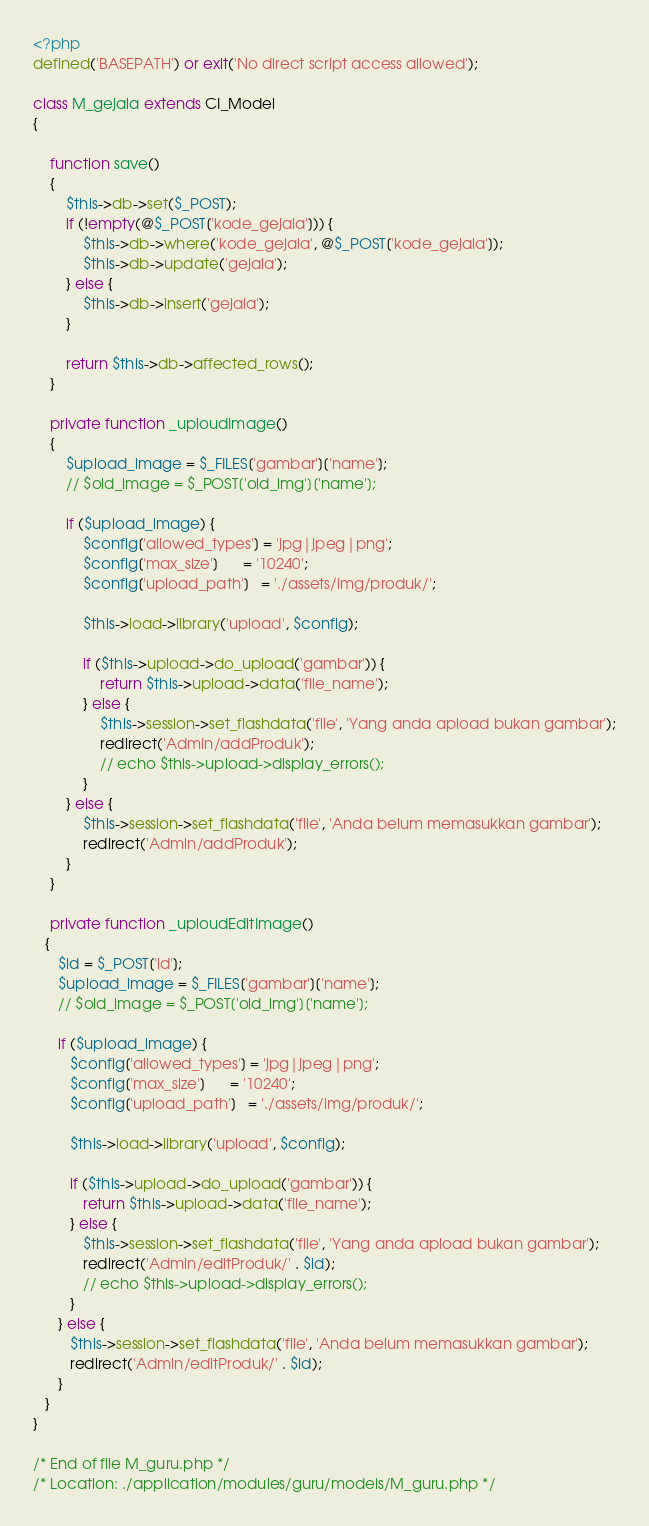Convert code to text. <code><loc_0><loc_0><loc_500><loc_500><_PHP_><?php
defined('BASEPATH') or exit('No direct script access allowed');

class M_gejala extends CI_Model
{

	function save()
	{
		$this->db->set($_POST);
		if (!empty(@$_POST['kode_gejala'])) {
			$this->db->where('kode_gejala', @$_POST['kode_gejala']);
			$this->db->update('gejala');
		} else {
			$this->db->insert('gejala');
		}

		return $this->db->affected_rows();
	}

	private function _uploudImage()
	{
		$upload_image = $_FILES['gambar']['name'];
		// $old_image = $_POST['old_img']['name'];

		if ($upload_image) {
			$config['allowed_types'] = 'jpg|jpeg|png';
			$config['max_size']      = '10240';
			$config['upload_path']   = './assets/img/produk/';

			$this->load->library('upload', $config);

			if ($this->upload->do_upload('gambar')) {
				return $this->upload->data('file_name');
			} else {
				$this->session->set_flashdata('file', 'Yang anda apload bukan gambar');
				redirect('Admin/addProduk');
				// echo $this->upload->display_errors();
			}
		} else {
			$this->session->set_flashdata('file', 'Anda belum memasukkan gambar');
			redirect('Admin/addProduk');
		}
	}

	private function _uploudEditImage()
   {
      $id = $_POST['id'];
      $upload_image = $_FILES['gambar']['name'];
      // $old_image = $_POST['old_img']['name'];

      if ($upload_image) {
         $config['allowed_types'] = 'jpg|jpeg|png';
         $config['max_size']      = '10240';
         $config['upload_path']   = './assets/img/produk/';

         $this->load->library('upload', $config);

         if ($this->upload->do_upload('gambar')) {
            return $this->upload->data('file_name');
         } else {
            $this->session->set_flashdata('file', 'Yang anda apload bukan gambar');
            redirect('Admin/editProduk/' . $id);
            // echo $this->upload->display_errors();
         }
      } else {
         $this->session->set_flashdata('file', 'Anda belum memasukkan gambar');
         redirect('Admin/editProduk/' . $id);
      }
   }
}

/* End of file M_guru.php */
/* Location: ./application/modules/guru/models/M_guru.php */
</code> 